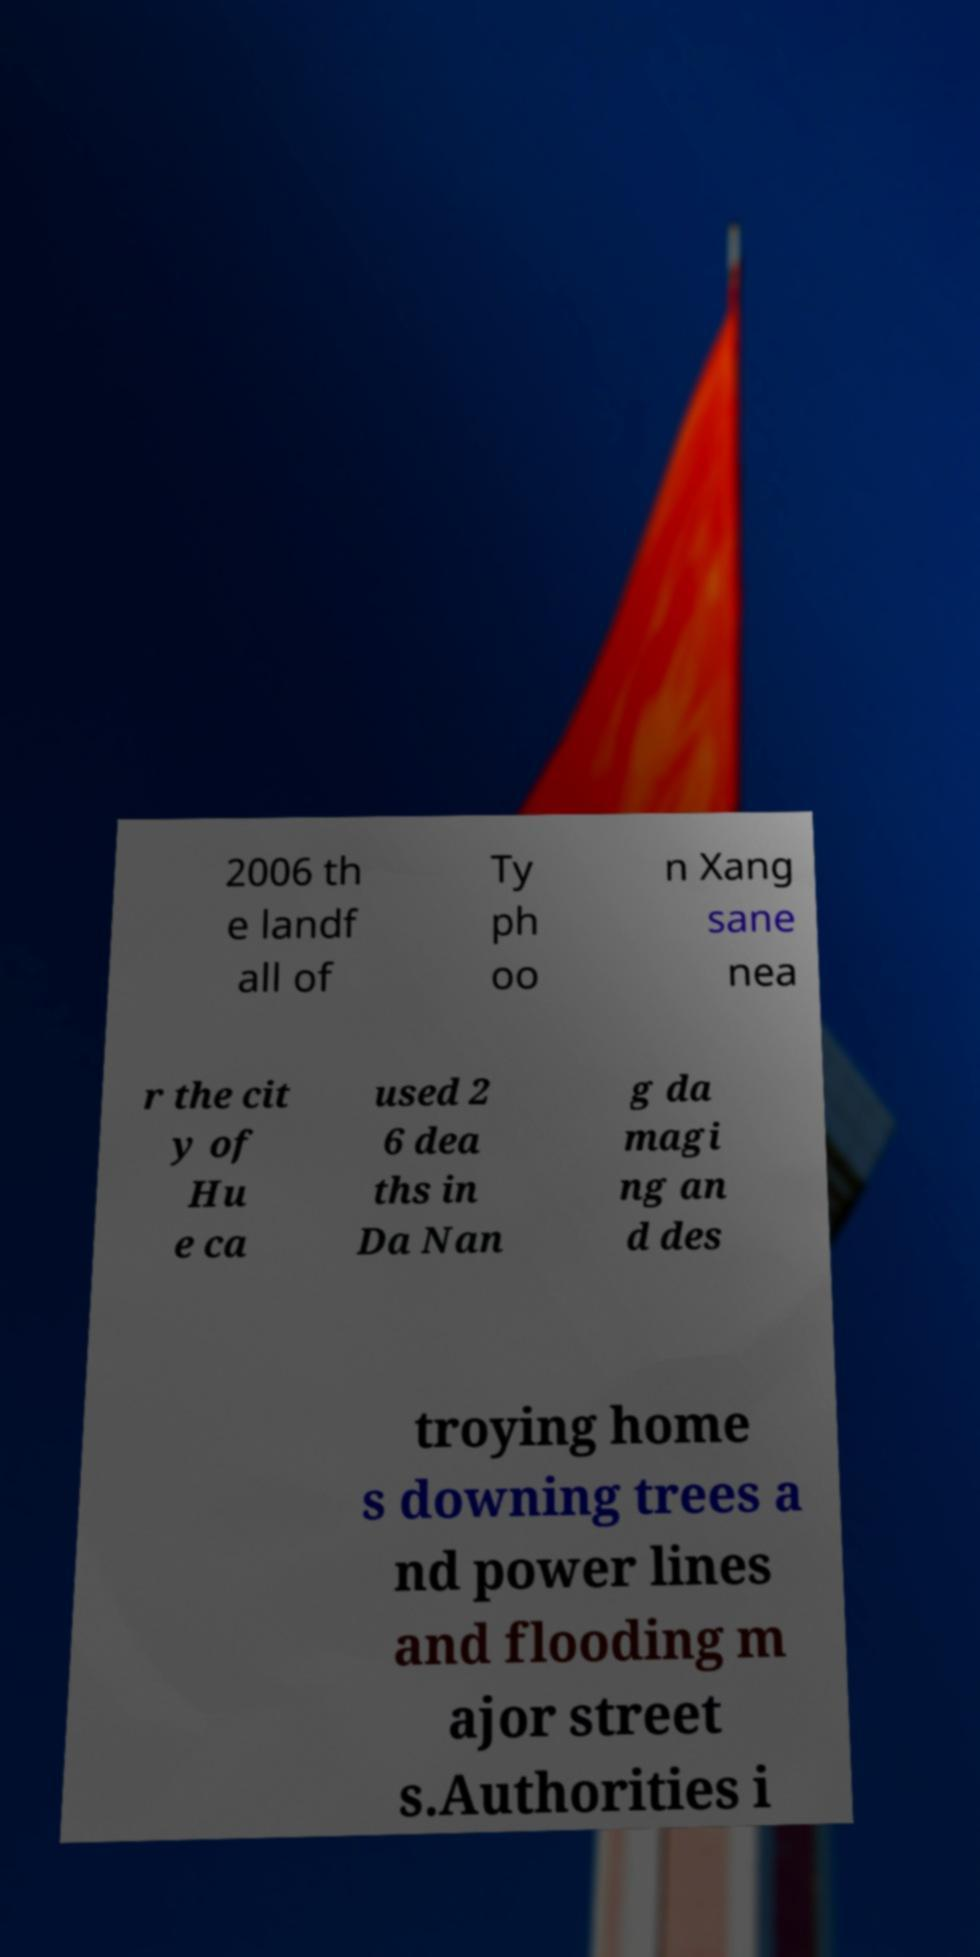Could you extract and type out the text from this image? 2006 th e landf all of Ty ph oo n Xang sane nea r the cit y of Hu e ca used 2 6 dea ths in Da Nan g da magi ng an d des troying home s downing trees a nd power lines and flooding m ajor street s.Authorities i 